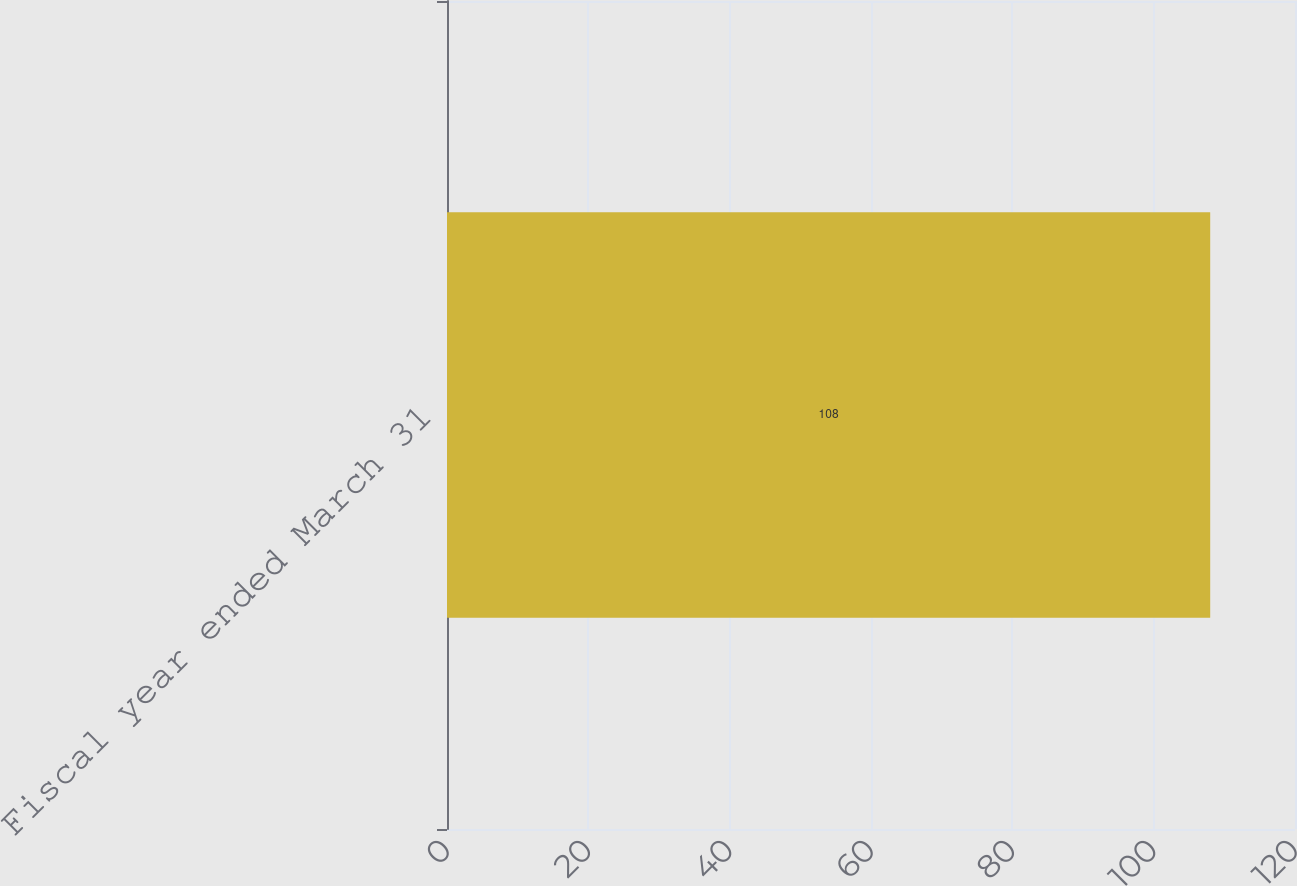Convert chart to OTSL. <chart><loc_0><loc_0><loc_500><loc_500><bar_chart><fcel>Fiscal year ended March 31<nl><fcel>108<nl></chart> 